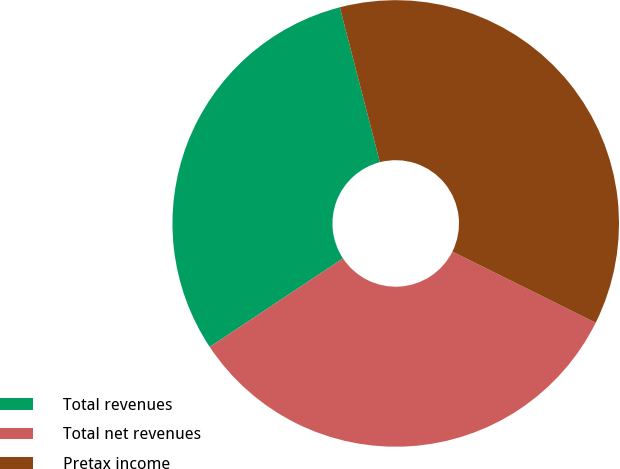Convert chart to OTSL. <chart><loc_0><loc_0><loc_500><loc_500><pie_chart><fcel>Total revenues<fcel>Total net revenues<fcel>Pretax income<nl><fcel>30.3%<fcel>33.33%<fcel>36.36%<nl></chart> 